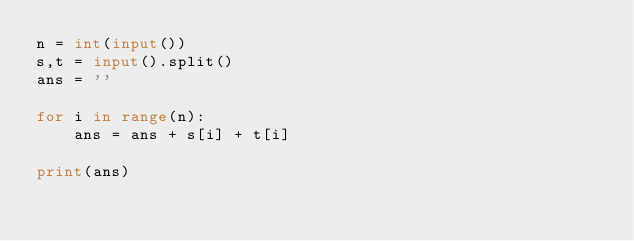<code> <loc_0><loc_0><loc_500><loc_500><_Python_>n = int(input())
s,t = input().split()
ans = ''

for i in range(n):
    ans = ans + s[i] + t[i]
    
print(ans)</code> 